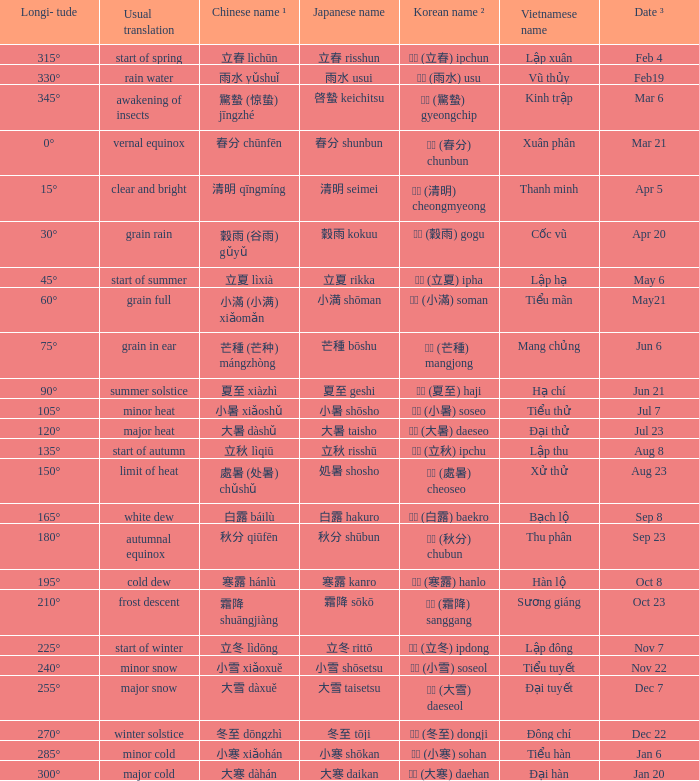On september 23, which translation is generally done? Autumnal equinox. 